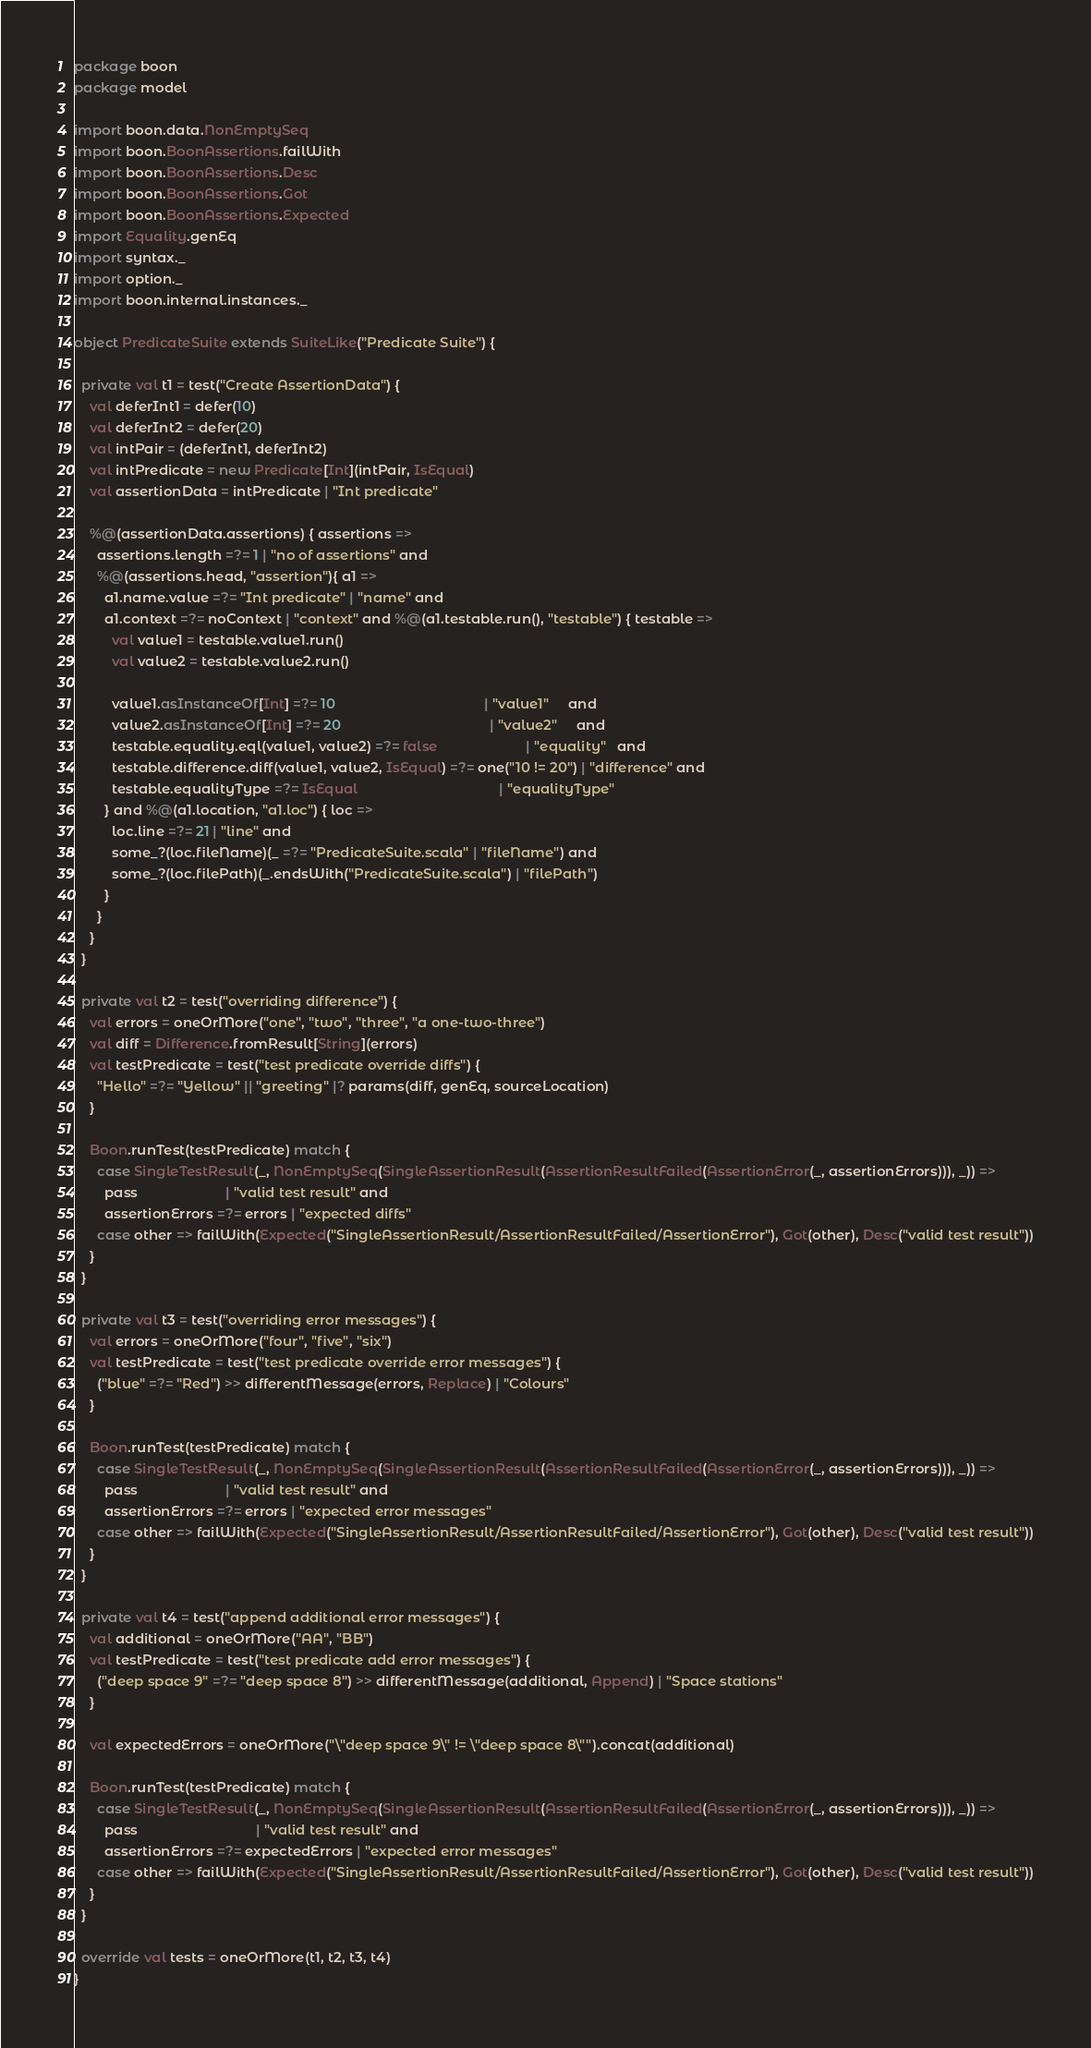Convert code to text. <code><loc_0><loc_0><loc_500><loc_500><_Scala_>package boon
package model

import boon.data.NonEmptySeq
import boon.BoonAssertions.failWith
import boon.BoonAssertions.Desc
import boon.BoonAssertions.Got
import boon.BoonAssertions.Expected
import Equality.genEq
import syntax._
import option._
import boon.internal.instances._

object PredicateSuite extends SuiteLike("Predicate Suite") {

  private val t1 = test("Create AssertionData") {
    val deferInt1 = defer(10)
    val deferInt2 = defer(20)
    val intPair = (deferInt1, deferInt2)
    val intPredicate = new Predicate[Int](intPair, IsEqual)
    val assertionData = intPredicate | "Int predicate"

    %@(assertionData.assertions) { assertions =>
      assertions.length =?= 1 | "no of assertions" and
      %@(assertions.head, "assertion"){ a1 =>
        a1.name.value =?= "Int predicate" | "name" and
        a1.context =?= noContext | "context" and %@(a1.testable.run(), "testable") { testable =>
          val value1 = testable.value1.run()
          val value2 = testable.value2.run()

          value1.asInstanceOf[Int] =?= 10                                       | "value1"     and
          value2.asInstanceOf[Int] =?= 20                                       | "value2"     and
          testable.equality.eql(value1, value2) =?= false                       | "equality"   and
          testable.difference.diff(value1, value2, IsEqual) =?= one("10 != 20") | "difference" and
          testable.equalityType =?= IsEqual                                     | "equalityType"
        } and %@(a1.location, "a1.loc") { loc =>
          loc.line =?= 21 | "line" and
          some_?(loc.fileName)(_ =?= "PredicateSuite.scala" | "fileName") and
          some_?(loc.filePath)(_.endsWith("PredicateSuite.scala") | "filePath")
        }
      }
    }
  }

  private val t2 = test("overriding difference") {
    val errors = oneOrMore("one", "two", "three", "a one-two-three")
    val diff = Difference.fromResult[String](errors)
    val testPredicate = test("test predicate override diffs") {
      "Hello" =?= "Yellow" || "greeting" |? params(diff, genEq, sourceLocation)
    }

    Boon.runTest(testPredicate) match {
      case SingleTestResult(_, NonEmptySeq(SingleAssertionResult(AssertionResultFailed(AssertionError(_, assertionErrors))), _)) =>
        pass                       | "valid test result" and
        assertionErrors =?= errors | "expected diffs"
      case other => failWith(Expected("SingleAssertionResult/AssertionResultFailed/AssertionError"), Got(other), Desc("valid test result"))
    }
  }

  private val t3 = test("overriding error messages") {
    val errors = oneOrMore("four", "five", "six")
    val testPredicate = test("test predicate override error messages") {
      ("blue" =?= "Red") >> differentMessage(errors, Replace) | "Colours"
    }

    Boon.runTest(testPredicate) match {
      case SingleTestResult(_, NonEmptySeq(SingleAssertionResult(AssertionResultFailed(AssertionError(_, assertionErrors))), _)) =>
        pass                       | "valid test result" and
        assertionErrors =?= errors | "expected error messages"
      case other => failWith(Expected("SingleAssertionResult/AssertionResultFailed/AssertionError"), Got(other), Desc("valid test result"))
    }
  }

  private val t4 = test("append additional error messages") {
    val additional = oneOrMore("AA", "BB")
    val testPredicate = test("test predicate add error messages") {
      ("deep space 9" =?= "deep space 8") >> differentMessage(additional, Append) | "Space stations"
    }

    val expectedErrors = oneOrMore("\"deep space 9\" != \"deep space 8\"").concat(additional)

    Boon.runTest(testPredicate) match {
      case SingleTestResult(_, NonEmptySeq(SingleAssertionResult(AssertionResultFailed(AssertionError(_, assertionErrors))), _)) =>
        pass                               | "valid test result" and
        assertionErrors =?= expectedErrors | "expected error messages"
      case other => failWith(Expected("SingleAssertionResult/AssertionResultFailed/AssertionError"), Got(other), Desc("valid test result"))
    }
  }

  override val tests = oneOrMore(t1, t2, t3, t4)
}</code> 